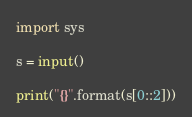Convert code to text. <code><loc_0><loc_0><loc_500><loc_500><_Python_>import sys

s = input()

print("{}".format(s[0::2]))</code> 